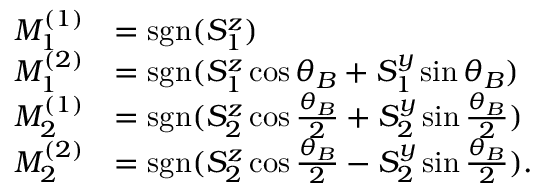<formula> <loc_0><loc_0><loc_500><loc_500>\begin{array} { r l } { M _ { 1 } ^ { ( 1 ) } } & { = s g n ( S _ { 1 } ^ { z } ) } \\ { M _ { 1 } ^ { ( 2 ) } } & { = s g n ( S _ { 1 } ^ { z } \cos \theta _ { B } + S _ { 1 } ^ { y } \sin \theta _ { B } ) } \\ { M _ { 2 } ^ { ( 1 ) } } & { = s g n ( S _ { 2 } ^ { z } \cos \frac { \theta _ { B } } { 2 } + S _ { 2 } ^ { y } \sin \frac { \theta _ { B } } { 2 } ) } \\ { M _ { 2 } ^ { ( 2 ) } } & { = s g n ( S _ { 2 } ^ { z } \cos \frac { \theta _ { B } } { 2 } - S _ { 2 } ^ { y } \sin \frac { \theta _ { B } } { 2 } ) . } \end{array}</formula> 